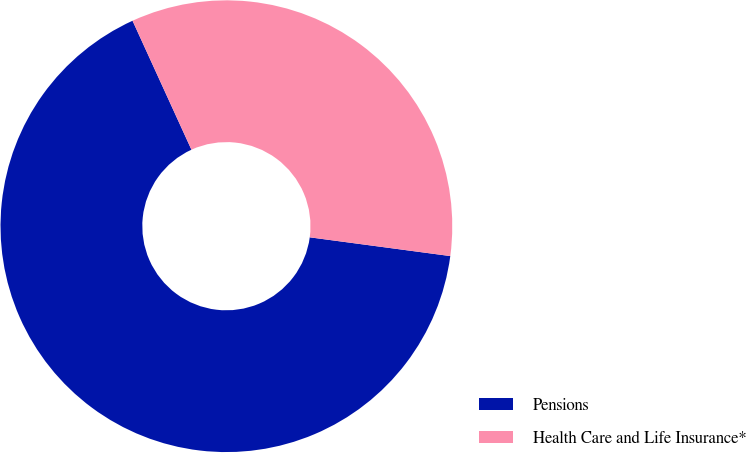Convert chart to OTSL. <chart><loc_0><loc_0><loc_500><loc_500><pie_chart><fcel>Pensions<fcel>Health Care and Life Insurance*<nl><fcel>66.07%<fcel>33.93%<nl></chart> 